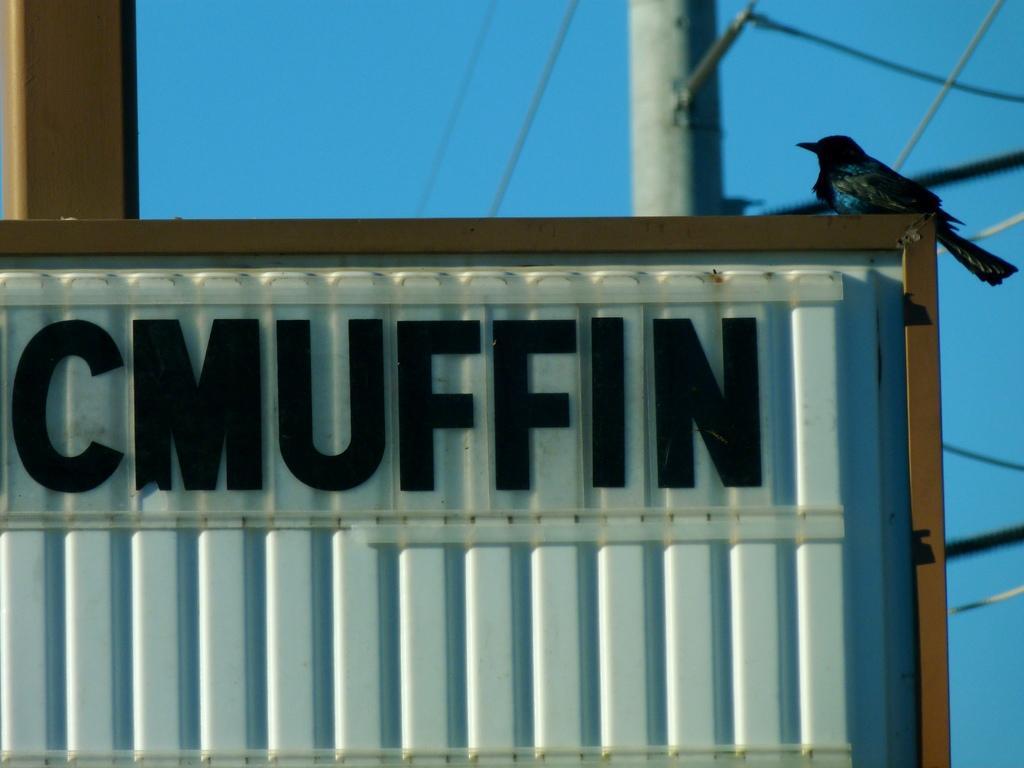Could you give a brief overview of what you see in this image? In this picture, it seems like text and a bird on a container in the foreground, there are wires and a pole in the background. 